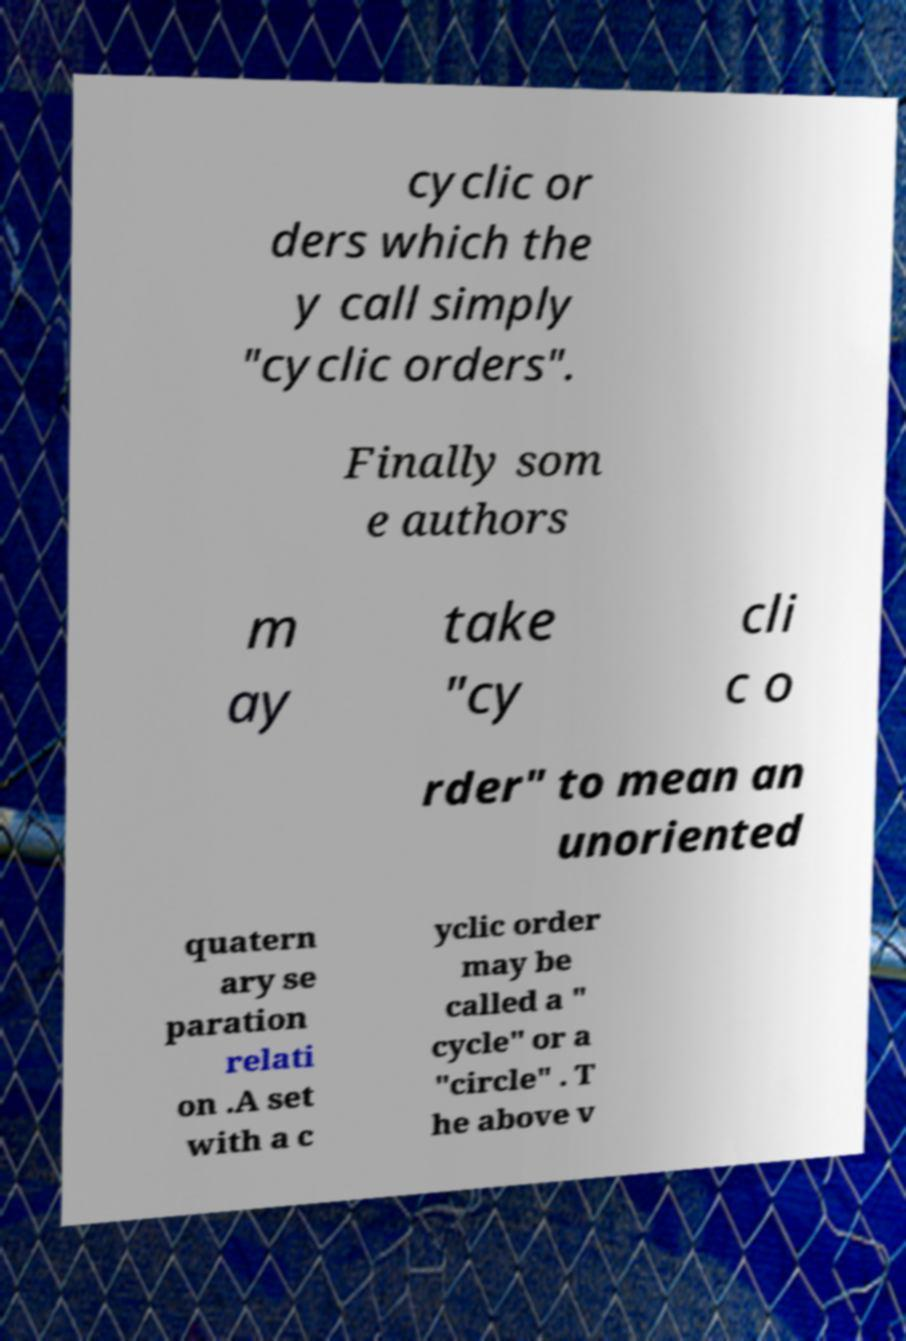Please read and relay the text visible in this image. What does it say? cyclic or ders which the y call simply "cyclic orders". Finally som e authors m ay take "cy cli c o rder" to mean an unoriented quatern ary se paration relati on .A set with a c yclic order may be called a " cycle" or a "circle" . T he above v 